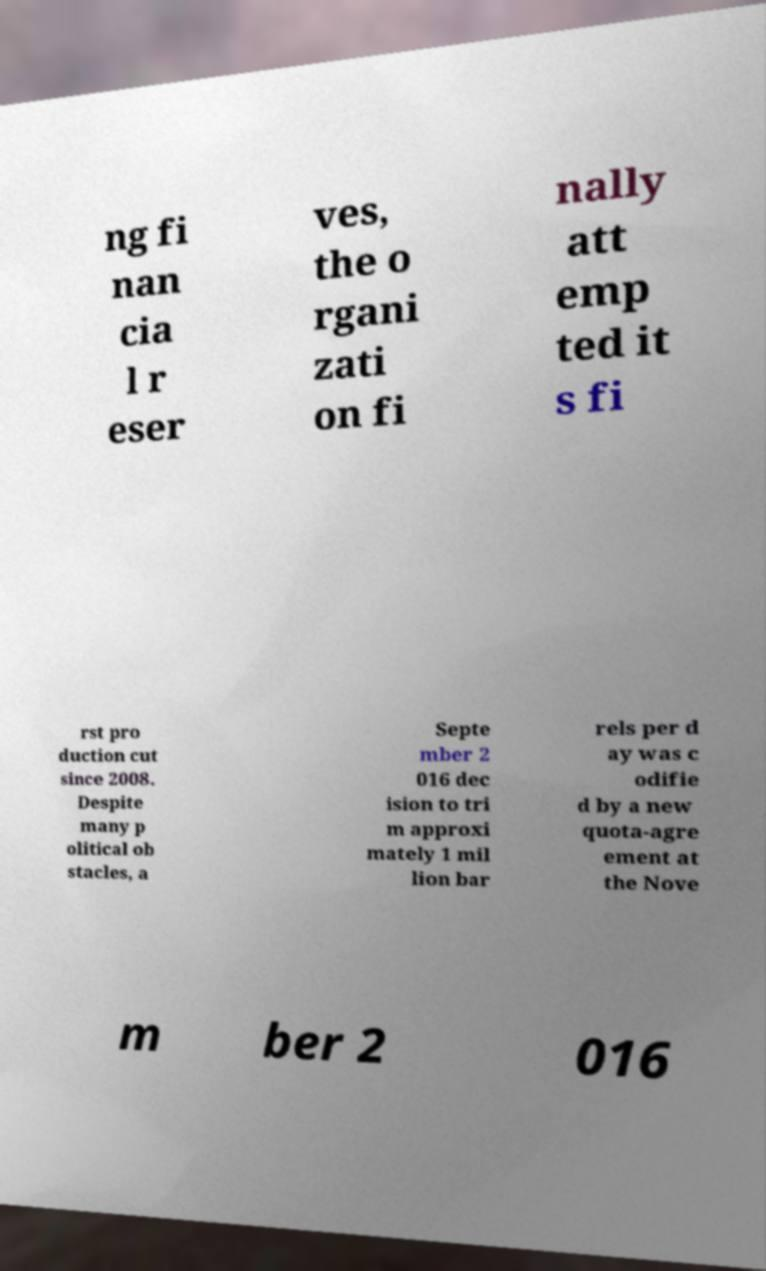Could you assist in decoding the text presented in this image and type it out clearly? ng fi nan cia l r eser ves, the o rgani zati on fi nally att emp ted it s fi rst pro duction cut since 2008. Despite many p olitical ob stacles, a Septe mber 2 016 dec ision to tri m approxi mately 1 mil lion bar rels per d ay was c odifie d by a new quota-agre ement at the Nove m ber 2 016 